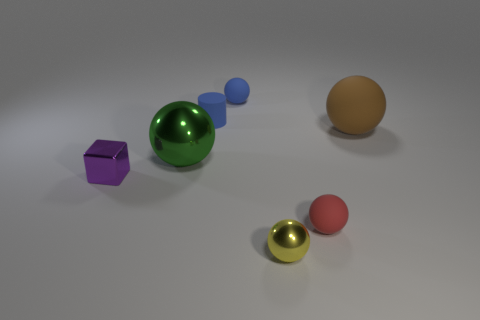Subtract 1 balls. How many balls are left? 4 Subtract all yellow balls. How many balls are left? 4 Subtract all blue balls. How many balls are left? 4 Subtract all green balls. Subtract all cyan cylinders. How many balls are left? 4 Add 1 large brown spheres. How many objects exist? 8 Subtract all cylinders. How many objects are left? 6 Subtract 1 purple cubes. How many objects are left? 6 Subtract all tiny red metallic balls. Subtract all spheres. How many objects are left? 2 Add 1 balls. How many balls are left? 6 Add 2 small cyan rubber spheres. How many small cyan rubber spheres exist? 2 